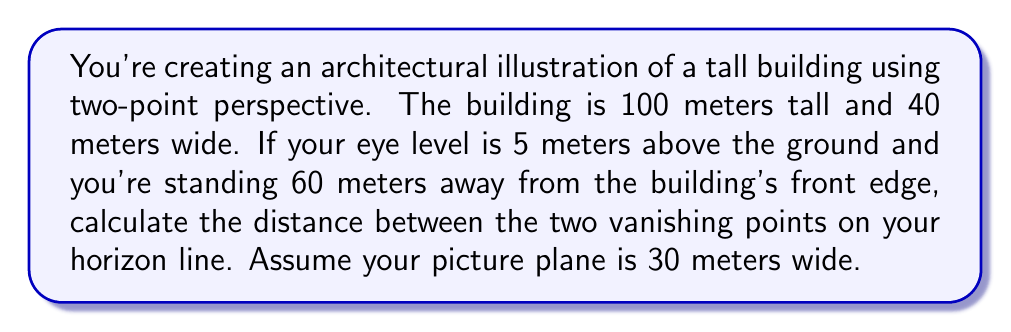Give your solution to this math problem. To solve this problem, we'll follow these steps:

1) First, we need to understand the relationship between the viewer, the object, and the picture plane in two-point perspective.

2) The distance between vanishing points (VPs) is determined by the viewer's cone of vision, which is typically about 60°.

3) We can calculate the distance to each VP using the following formula:

   $$\text{Distance to VP} = \frac{\text{Width of picture plane}}{2 \tan(\frac{\text{Angle of view}}{2})}$$

4) In this case:
   - Width of picture plane = 30 meters
   - Angle of view = 60° = π/3 radians

5) Let's calculate:

   $$\text{Distance to VP} = \frac{30}{2 \tan(\frac{\pi}{6})} = \frac{30}{2 \cdot \frac{1}{\sqrt{3}}} = \frac{30\sqrt{3}}{2} \approx 25.98 \text{ meters}$$

6) The distance between the two VPs is twice this value:

   $$\text{Distance between VPs} = 2 \cdot \frac{30\sqrt{3}}{2} = 30\sqrt{3} \approx 51.96 \text{ meters}$$

This result gives us the distance between the vanishing points on our horizon line in the picture plane.

[asy]
unitsize(2mm);
pair A = (0,0), B = (100,0), C = (50,50);
draw(A--B--C--A);
label("Picture Plane", (50,-5), S);
label("60°", (50,5), N);
label("VP1", A, SW);
label("VP2", B, SE);
draw((-10,0)--(110,0), dashed);
label("Horizon Line", (110,0), E);
[/asy]
Answer: The distance between the two vanishing points on the horizon line is $30\sqrt{3}$ meters, or approximately 51.96 meters. 